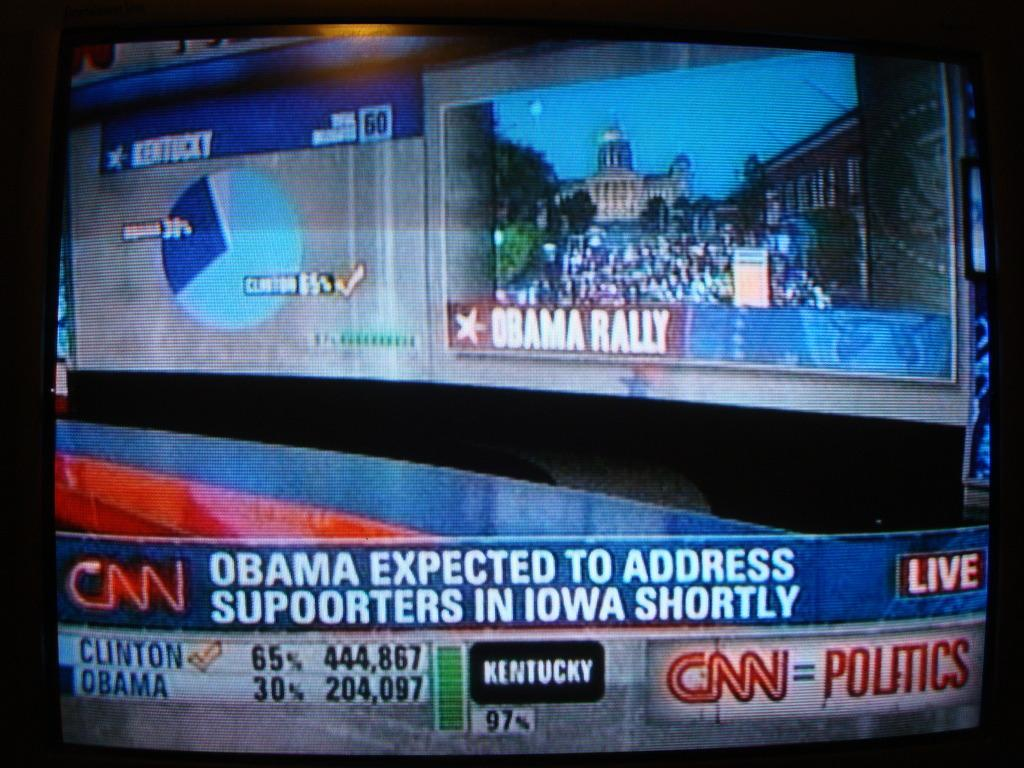What is the main object in the image? There is a display of a television in the image. What type of pain is the television experiencing in the image? There is no indication in the image that the television is experiencing any pain, as televisions are inanimate objects and cannot feel pain. 